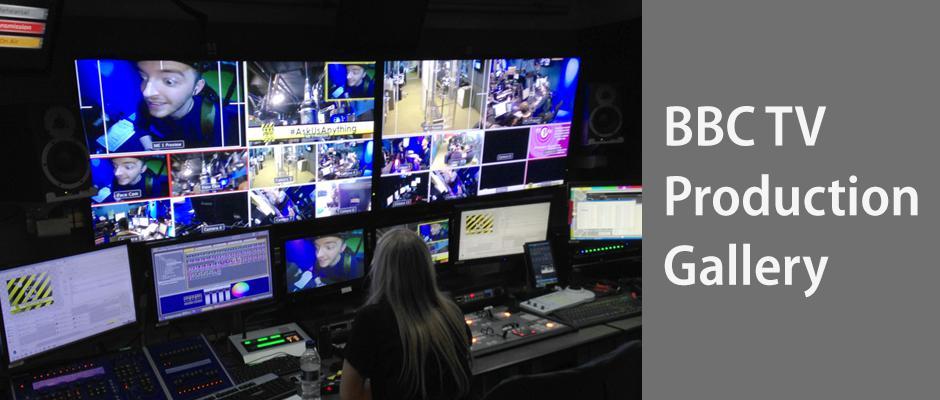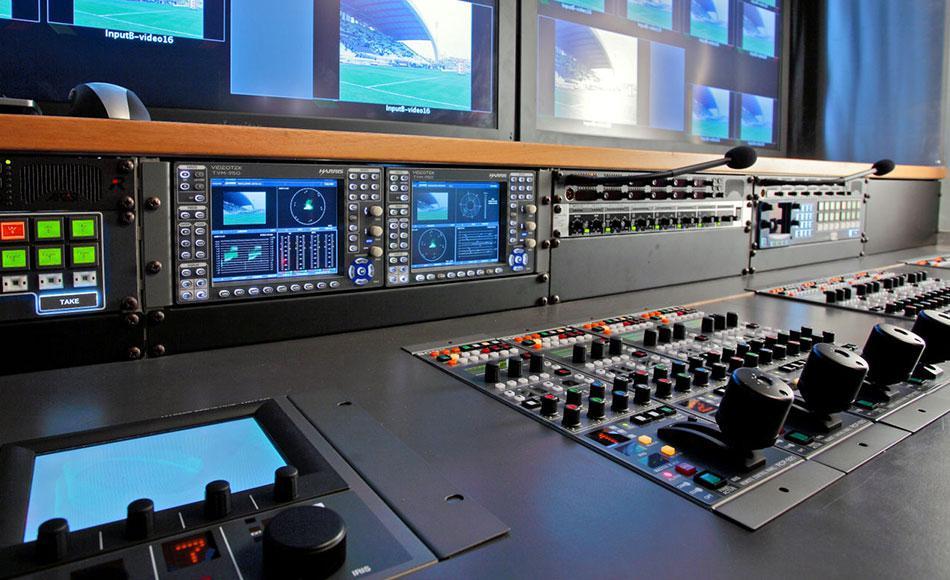The first image is the image on the left, the second image is the image on the right. Assess this claim about the two images: "There is at least one person in the image on the left.". Correct or not? Answer yes or no. Yes. 